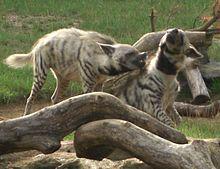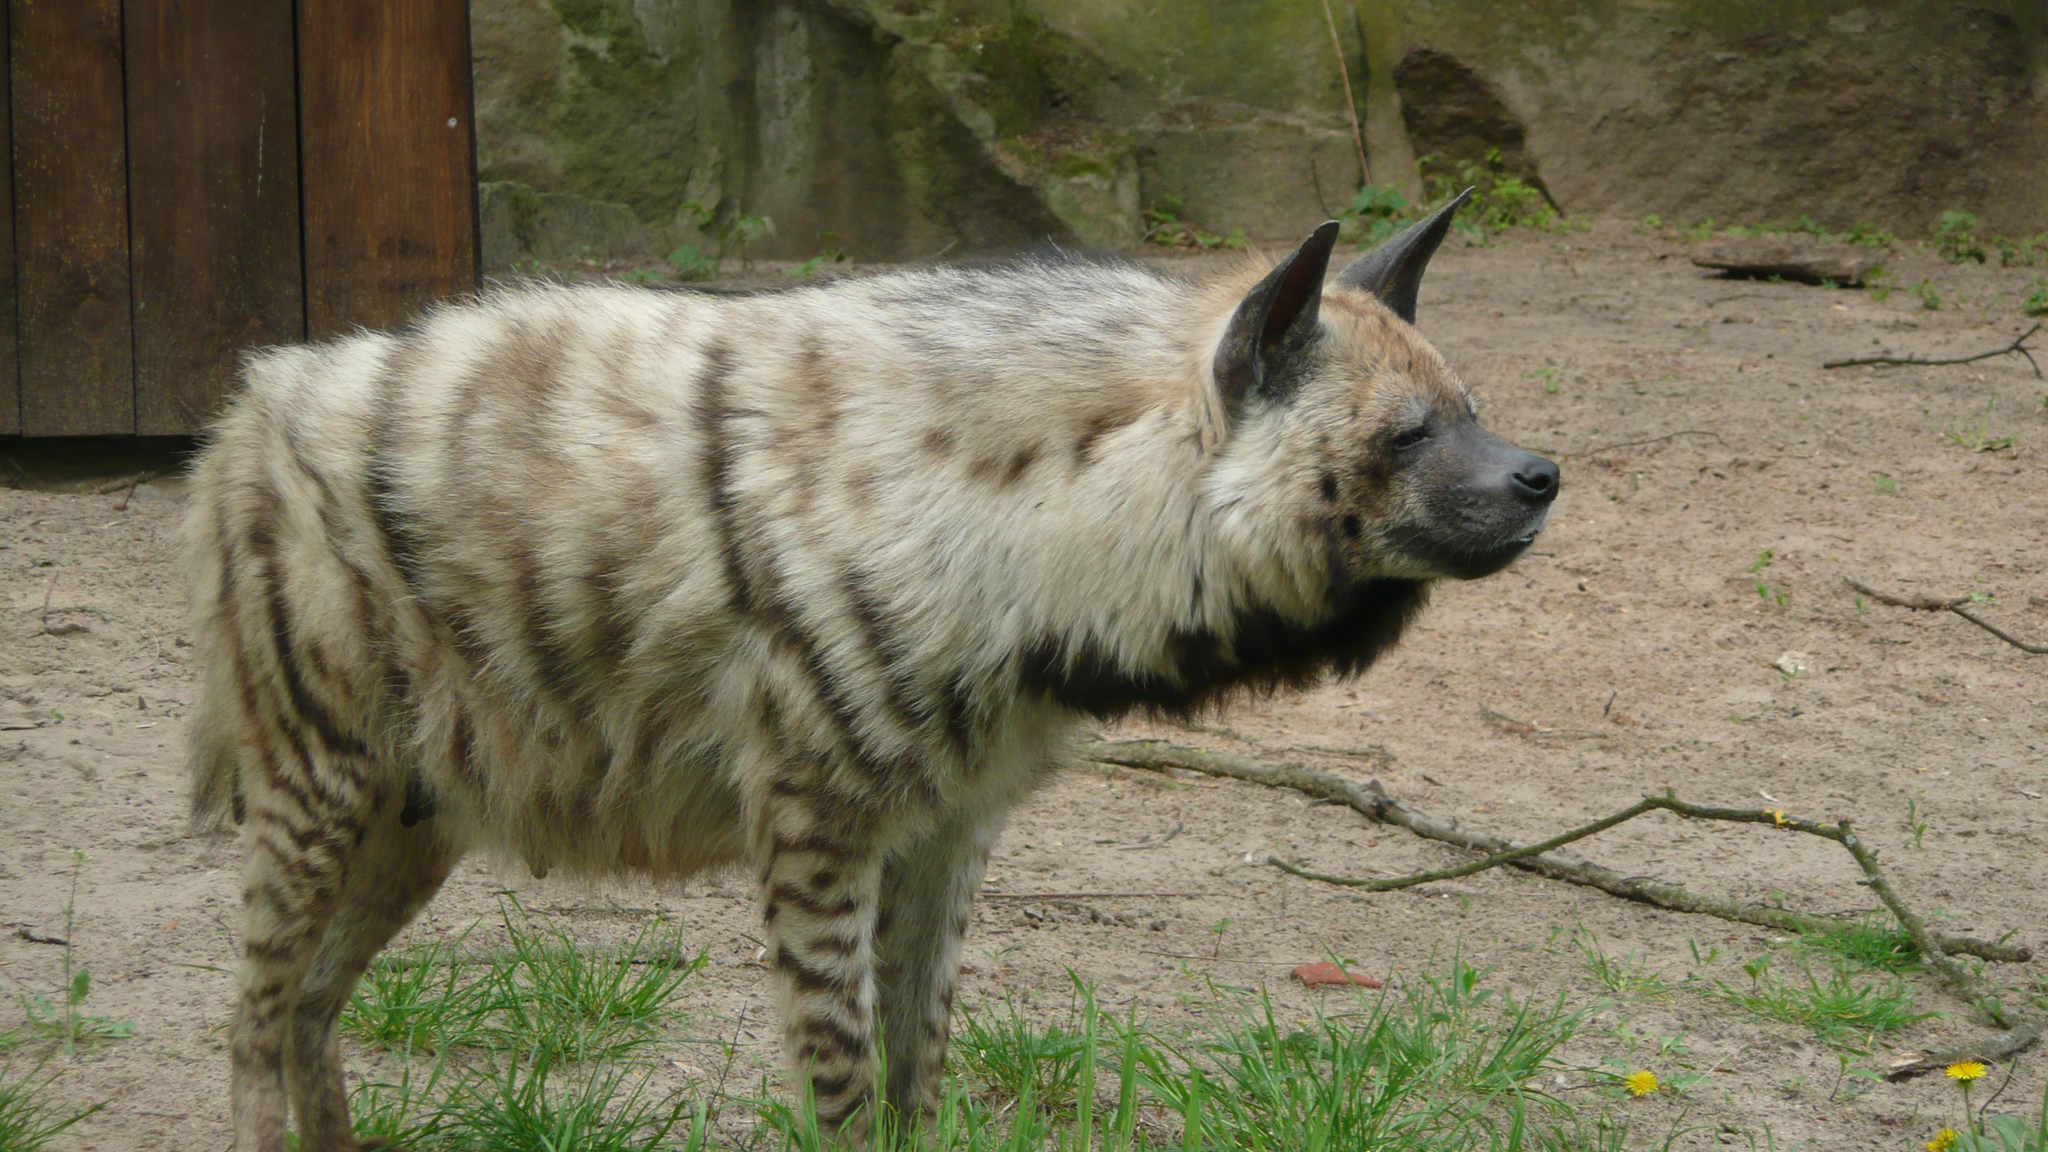The first image is the image on the left, the second image is the image on the right. Evaluate the accuracy of this statement regarding the images: "An image shows only one hyena, with its head and body turned to the camera.". Is it true? Answer yes or no. No. The first image is the image on the left, the second image is the image on the right. Analyze the images presented: Is the assertion "The animal in one of the images has its body turned toward the camera." valid? Answer yes or no. No. 